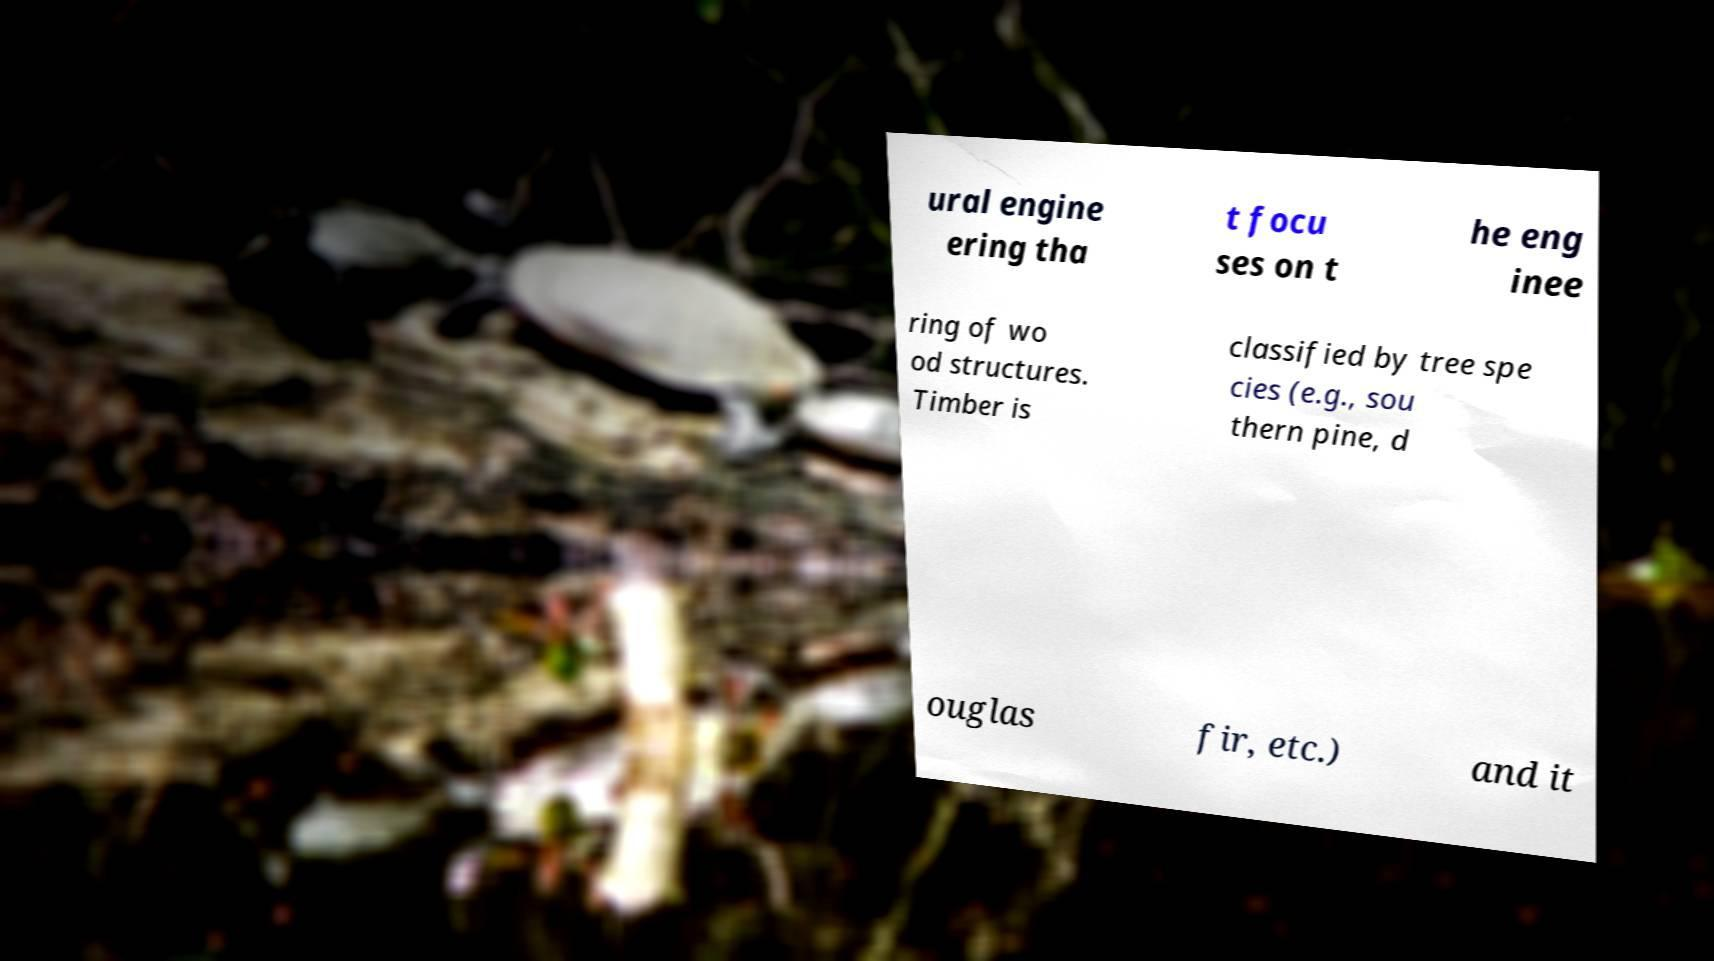Could you assist in decoding the text presented in this image and type it out clearly? ural engine ering tha t focu ses on t he eng inee ring of wo od structures. Timber is classified by tree spe cies (e.g., sou thern pine, d ouglas fir, etc.) and it 